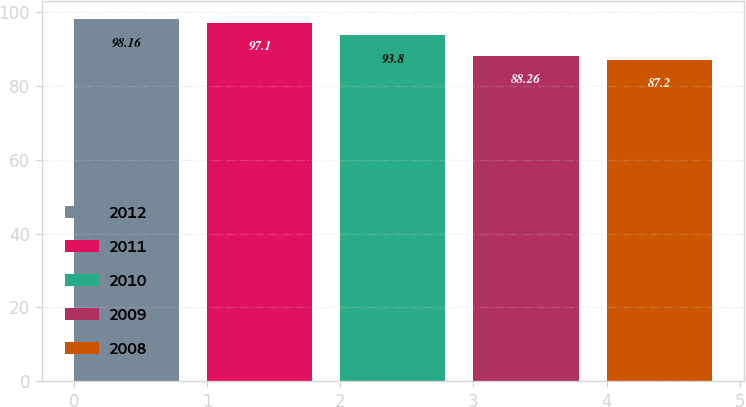Convert chart to OTSL. <chart><loc_0><loc_0><loc_500><loc_500><bar_chart><fcel>2012<fcel>2011<fcel>2010<fcel>2009<fcel>2008<nl><fcel>98.16<fcel>97.1<fcel>93.8<fcel>88.26<fcel>87.2<nl></chart> 